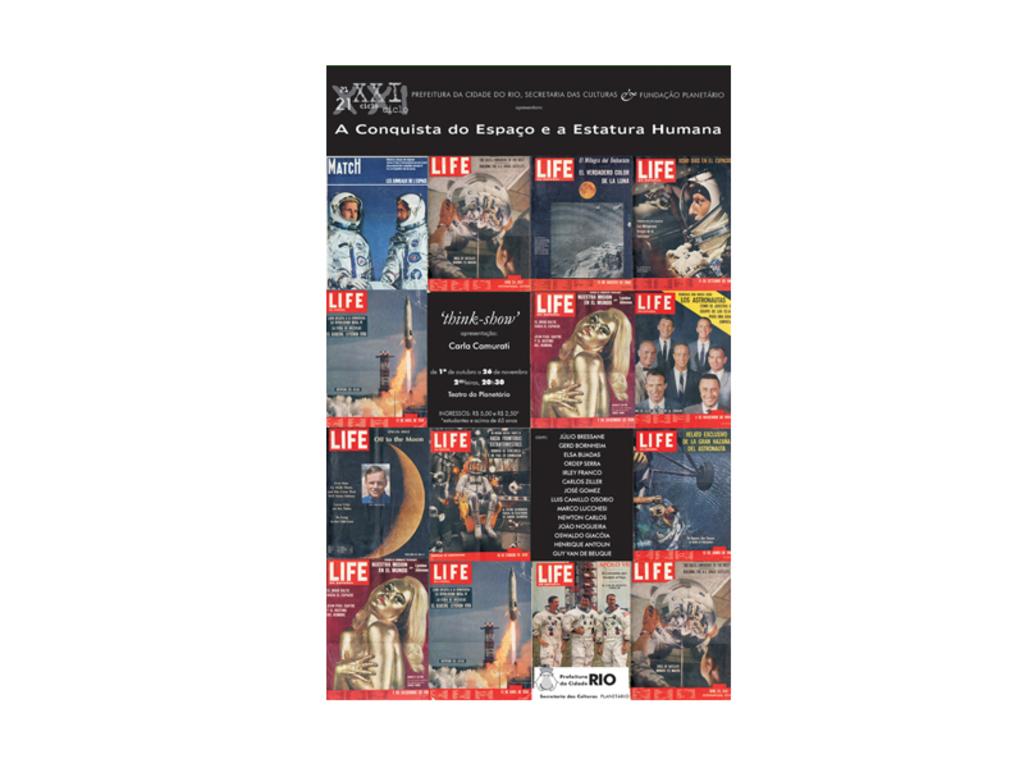What magazine is this?
Make the answer very short. Life. What city is listed on the white section under the photo of astronauts?
Keep it short and to the point. Rio. 